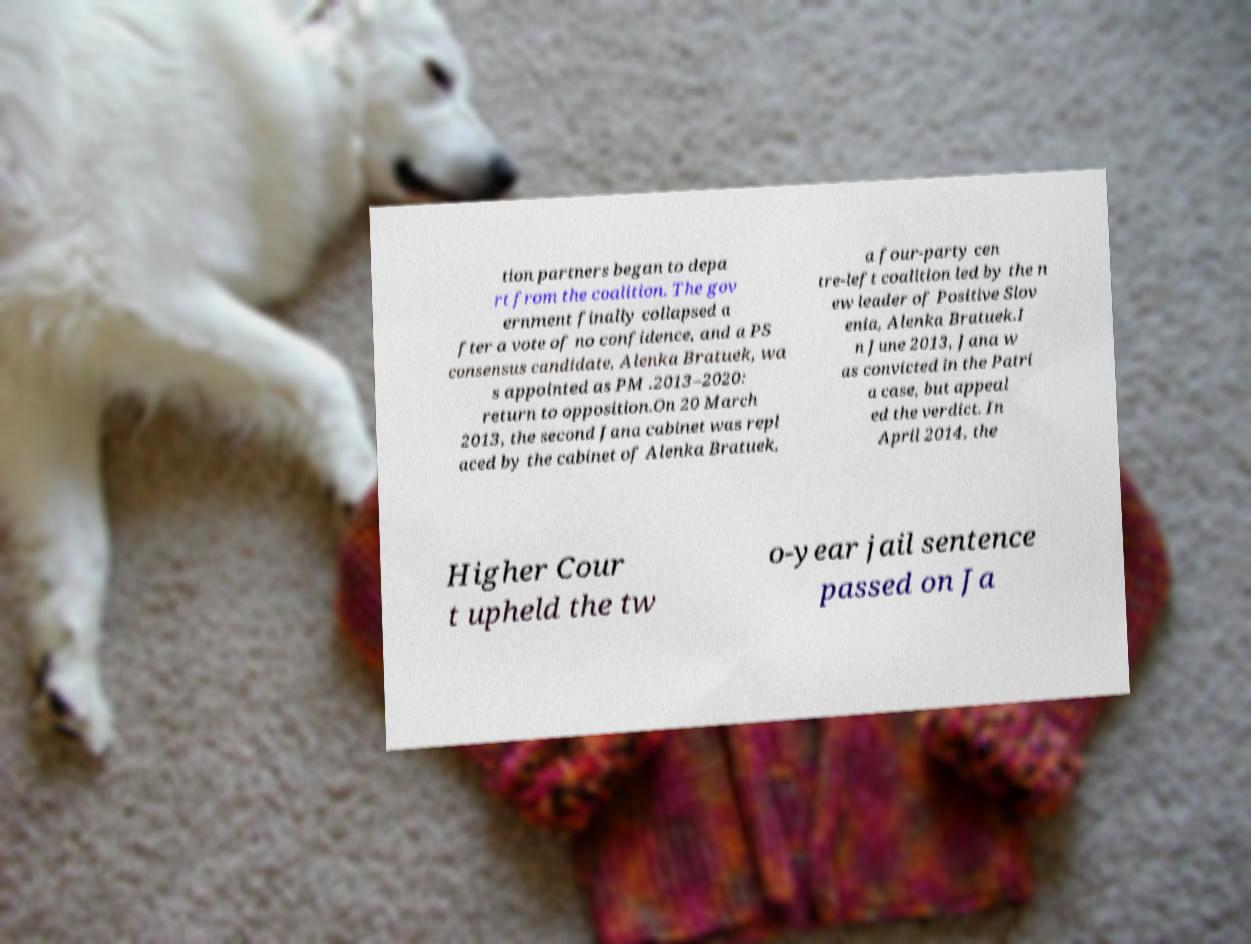Can you read and provide the text displayed in the image?This photo seems to have some interesting text. Can you extract and type it out for me? tion partners began to depa rt from the coalition. The gov ernment finally collapsed a fter a vote of no confidence, and a PS consensus candidate, Alenka Bratuek, wa s appointed as PM .2013–2020: return to opposition.On 20 March 2013, the second Jana cabinet was repl aced by the cabinet of Alenka Bratuek, a four-party cen tre-left coalition led by the n ew leader of Positive Slov enia, Alenka Bratuek.I n June 2013, Jana w as convicted in the Patri a case, but appeal ed the verdict. In April 2014, the Higher Cour t upheld the tw o-year jail sentence passed on Ja 